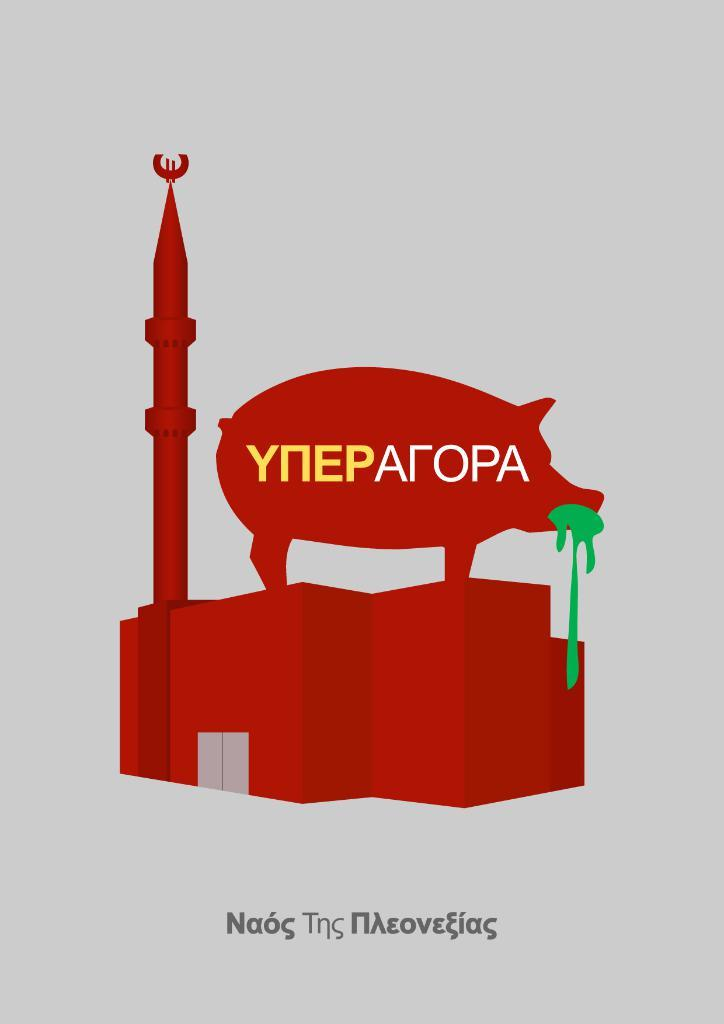<image>
Render a clear and concise summary of the photo. a red pig with letter EP has a green mouth and other Cyrillic letters 